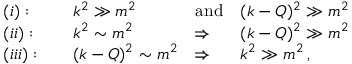<formula> <loc_0><loc_0><loc_500><loc_500>\begin{array} { l l l l } { ( i ) \colon \quad } & { { k ^ { 2 } \gg m ^ { 2 } \quad } } & { a n d } & { { ( k - Q ) ^ { 2 } \gg m ^ { 2 } } } \\ { ( i i ) \colon \quad } & { { k ^ { 2 } \sim m ^ { 2 } } } & { \Rightarrow } & { { ( k - Q ) ^ { 2 } \gg m ^ { 2 } } } \\ { ( i i i ) \colon \quad } & { { ( k - Q ) ^ { 2 } \sim m ^ { 2 } } } & { \Rightarrow } & { { k ^ { 2 } \gg m ^ { 2 } \, , } } \end{array}</formula> 